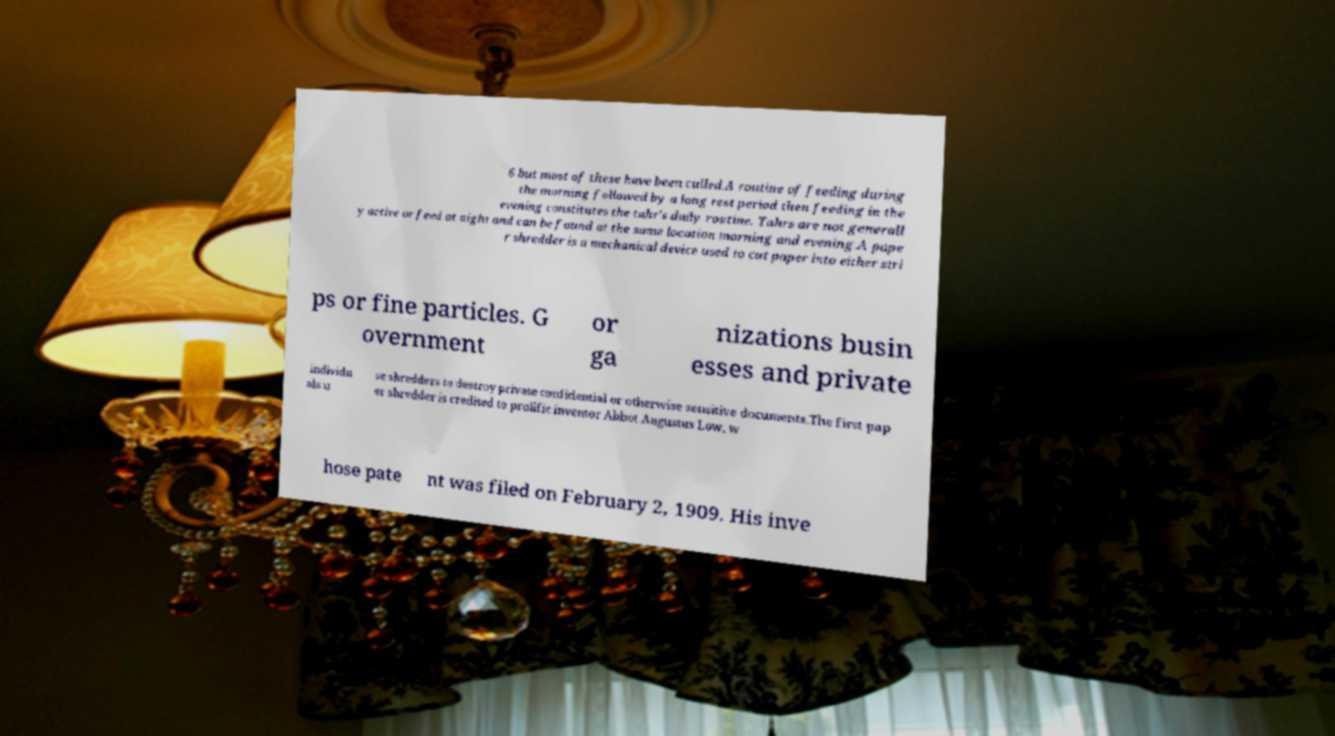Please identify and transcribe the text found in this image. 6 but most of these have been culled.A routine of feeding during the morning followed by a long rest period then feeding in the evening constitutes the tahr's daily routine. Tahrs are not generall y active or feed at night and can be found at the same location morning and evening.A pape r shredder is a mechanical device used to cut paper into either stri ps or fine particles. G overnment or ga nizations busin esses and private individu als u se shredders to destroy private confidential or otherwise sensitive documents.The first pap er shredder is credited to prolific inventor Abbot Augustus Low, w hose pate nt was filed on February 2, 1909. His inve 